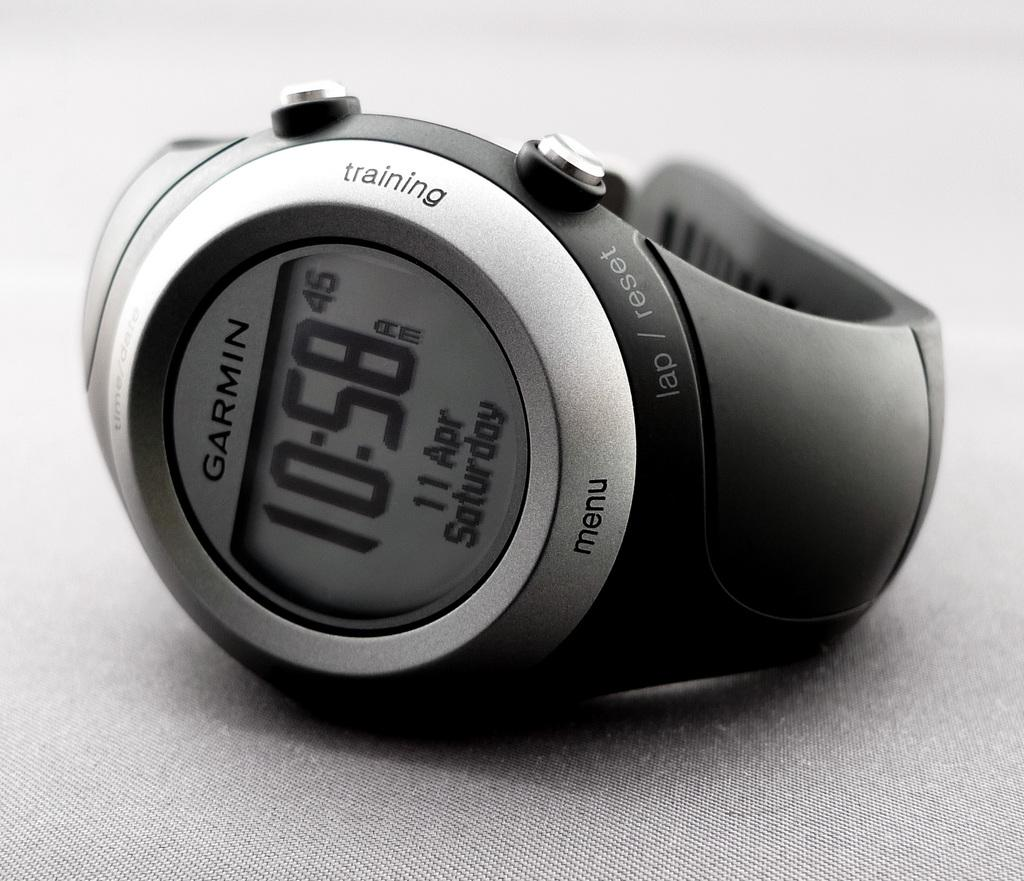<image>
Share a concise interpretation of the image provided. A Garmin digital watch says that today is Saturday. 